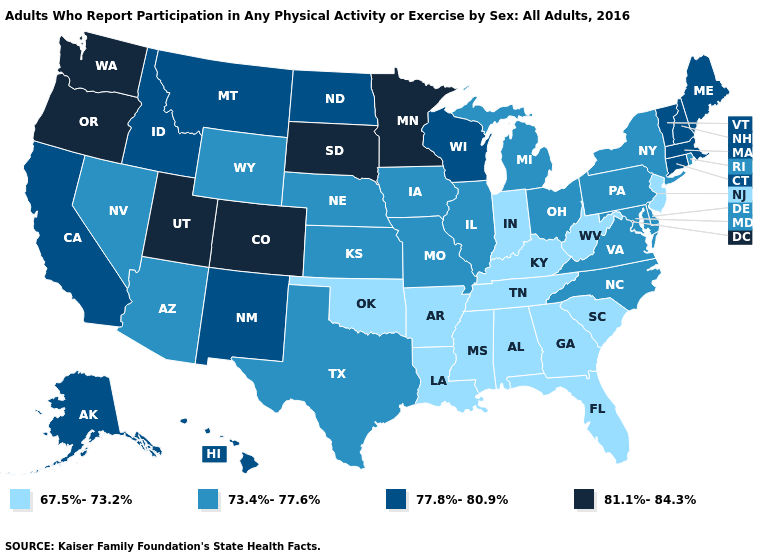What is the value of Arizona?
Concise answer only. 73.4%-77.6%. Does Colorado have the highest value in the USA?
Concise answer only. Yes. What is the highest value in states that border Mississippi?
Be succinct. 67.5%-73.2%. Does the first symbol in the legend represent the smallest category?
Write a very short answer. Yes. What is the lowest value in the Northeast?
Give a very brief answer. 67.5%-73.2%. What is the value of Georgia?
Be succinct. 67.5%-73.2%. What is the value of Washington?
Short answer required. 81.1%-84.3%. What is the value of Louisiana?
Be succinct. 67.5%-73.2%. What is the value of Pennsylvania?
Concise answer only. 73.4%-77.6%. What is the value of Nevada?
Give a very brief answer. 73.4%-77.6%. What is the lowest value in the USA?
Write a very short answer. 67.5%-73.2%. Among the states that border Alabama , which have the highest value?
Quick response, please. Florida, Georgia, Mississippi, Tennessee. Does Florida have a lower value than Kentucky?
Short answer required. No. How many symbols are there in the legend?
Write a very short answer. 4. Among the states that border Arizona , which have the highest value?
Give a very brief answer. Colorado, Utah. 